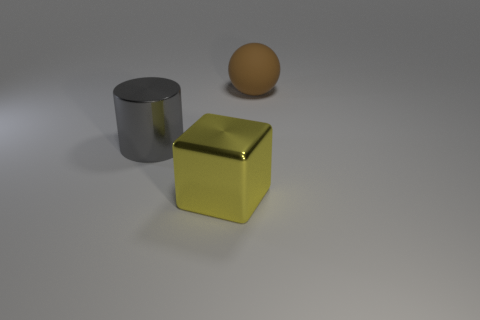Subtract all blocks. How many objects are left? 2 Add 2 green spheres. How many objects exist? 5 Subtract all red cylinders. Subtract all cyan blocks. How many cylinders are left? 1 Subtract all blue spheres. How many purple cylinders are left? 0 Subtract all yellow shiny things. Subtract all large gray metal cylinders. How many objects are left? 1 Add 2 large yellow metal objects. How many large yellow metal objects are left? 3 Add 1 large gray metal cylinders. How many large gray metal cylinders exist? 2 Subtract 0 cyan cylinders. How many objects are left? 3 